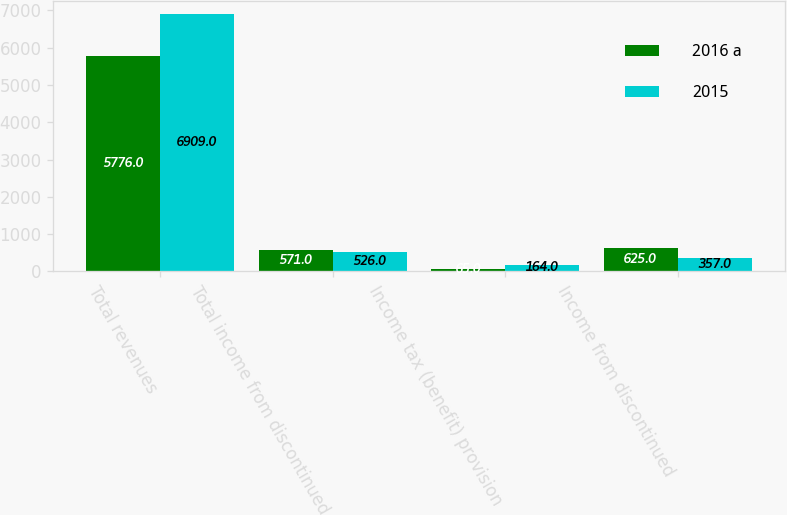Convert chart. <chart><loc_0><loc_0><loc_500><loc_500><stacked_bar_chart><ecel><fcel>Total revenues<fcel>Total income from discontinued<fcel>Income tax (benefit) provision<fcel>Income from discontinued<nl><fcel>2016 a<fcel>5776<fcel>571<fcel>65<fcel>625<nl><fcel>2015<fcel>6909<fcel>526<fcel>164<fcel>357<nl></chart> 